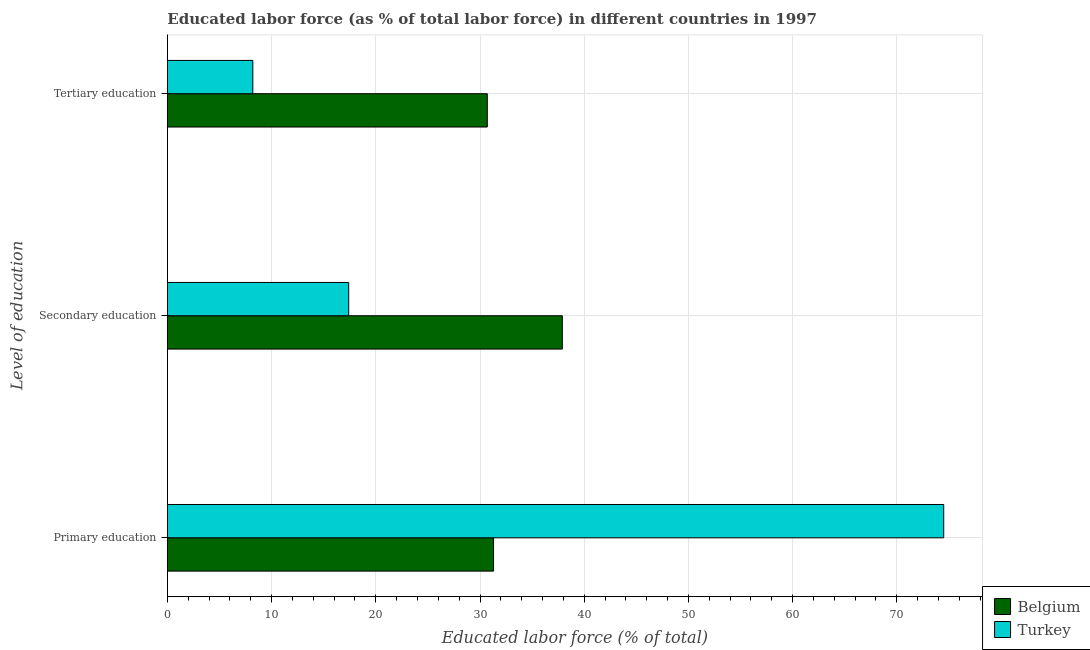How many different coloured bars are there?
Keep it short and to the point. 2. How many groups of bars are there?
Provide a succinct answer. 3. How many bars are there on the 3rd tick from the top?
Provide a succinct answer. 2. What is the label of the 1st group of bars from the top?
Ensure brevity in your answer.  Tertiary education. What is the percentage of labor force who received secondary education in Turkey?
Ensure brevity in your answer.  17.4. Across all countries, what is the maximum percentage of labor force who received primary education?
Give a very brief answer. 74.5. Across all countries, what is the minimum percentage of labor force who received secondary education?
Provide a succinct answer. 17.4. In which country was the percentage of labor force who received primary education minimum?
Ensure brevity in your answer.  Belgium. What is the total percentage of labor force who received tertiary education in the graph?
Your answer should be very brief. 38.9. What is the difference between the percentage of labor force who received primary education in Turkey and that in Belgium?
Provide a short and direct response. 43.2. What is the difference between the percentage of labor force who received primary education in Belgium and the percentage of labor force who received tertiary education in Turkey?
Keep it short and to the point. 23.1. What is the average percentage of labor force who received tertiary education per country?
Your answer should be very brief. 19.45. What is the difference between the percentage of labor force who received tertiary education and percentage of labor force who received primary education in Belgium?
Your answer should be very brief. -0.6. What is the ratio of the percentage of labor force who received secondary education in Turkey to that in Belgium?
Your answer should be compact. 0.46. What is the difference between the highest and the second highest percentage of labor force who received tertiary education?
Your answer should be very brief. 22.5. What is the difference between the highest and the lowest percentage of labor force who received primary education?
Provide a short and direct response. 43.2. What does the 1st bar from the top in Tertiary education represents?
Make the answer very short. Turkey. What does the 1st bar from the bottom in Tertiary education represents?
Give a very brief answer. Belgium. Is it the case that in every country, the sum of the percentage of labor force who received primary education and percentage of labor force who received secondary education is greater than the percentage of labor force who received tertiary education?
Give a very brief answer. Yes. How many bars are there?
Your answer should be very brief. 6. Are all the bars in the graph horizontal?
Offer a terse response. Yes. How many countries are there in the graph?
Your answer should be very brief. 2. What is the difference between two consecutive major ticks on the X-axis?
Provide a short and direct response. 10. Are the values on the major ticks of X-axis written in scientific E-notation?
Your answer should be compact. No. Does the graph contain any zero values?
Give a very brief answer. No. Does the graph contain grids?
Provide a short and direct response. Yes. Where does the legend appear in the graph?
Offer a very short reply. Bottom right. How many legend labels are there?
Your response must be concise. 2. How are the legend labels stacked?
Make the answer very short. Vertical. What is the title of the graph?
Make the answer very short. Educated labor force (as % of total labor force) in different countries in 1997. Does "Bahrain" appear as one of the legend labels in the graph?
Your answer should be very brief. No. What is the label or title of the X-axis?
Your answer should be compact. Educated labor force (% of total). What is the label or title of the Y-axis?
Give a very brief answer. Level of education. What is the Educated labor force (% of total) in Belgium in Primary education?
Provide a succinct answer. 31.3. What is the Educated labor force (% of total) in Turkey in Primary education?
Your answer should be very brief. 74.5. What is the Educated labor force (% of total) of Belgium in Secondary education?
Make the answer very short. 37.9. What is the Educated labor force (% of total) of Turkey in Secondary education?
Your response must be concise. 17.4. What is the Educated labor force (% of total) in Belgium in Tertiary education?
Make the answer very short. 30.7. What is the Educated labor force (% of total) in Turkey in Tertiary education?
Provide a succinct answer. 8.2. Across all Level of education, what is the maximum Educated labor force (% of total) of Belgium?
Give a very brief answer. 37.9. Across all Level of education, what is the maximum Educated labor force (% of total) in Turkey?
Provide a succinct answer. 74.5. Across all Level of education, what is the minimum Educated labor force (% of total) of Belgium?
Your answer should be compact. 30.7. Across all Level of education, what is the minimum Educated labor force (% of total) of Turkey?
Your answer should be very brief. 8.2. What is the total Educated labor force (% of total) of Belgium in the graph?
Your answer should be compact. 99.9. What is the total Educated labor force (% of total) in Turkey in the graph?
Provide a short and direct response. 100.1. What is the difference between the Educated labor force (% of total) in Belgium in Primary education and that in Secondary education?
Your response must be concise. -6.6. What is the difference between the Educated labor force (% of total) in Turkey in Primary education and that in Secondary education?
Offer a terse response. 57.1. What is the difference between the Educated labor force (% of total) of Turkey in Primary education and that in Tertiary education?
Offer a terse response. 66.3. What is the difference between the Educated labor force (% of total) in Turkey in Secondary education and that in Tertiary education?
Provide a succinct answer. 9.2. What is the difference between the Educated labor force (% of total) of Belgium in Primary education and the Educated labor force (% of total) of Turkey in Secondary education?
Your response must be concise. 13.9. What is the difference between the Educated labor force (% of total) in Belgium in Primary education and the Educated labor force (% of total) in Turkey in Tertiary education?
Make the answer very short. 23.1. What is the difference between the Educated labor force (% of total) in Belgium in Secondary education and the Educated labor force (% of total) in Turkey in Tertiary education?
Provide a succinct answer. 29.7. What is the average Educated labor force (% of total) in Belgium per Level of education?
Provide a short and direct response. 33.3. What is the average Educated labor force (% of total) in Turkey per Level of education?
Ensure brevity in your answer.  33.37. What is the difference between the Educated labor force (% of total) of Belgium and Educated labor force (% of total) of Turkey in Primary education?
Your answer should be compact. -43.2. What is the difference between the Educated labor force (% of total) of Belgium and Educated labor force (% of total) of Turkey in Secondary education?
Your response must be concise. 20.5. What is the ratio of the Educated labor force (% of total) in Belgium in Primary education to that in Secondary education?
Your response must be concise. 0.83. What is the ratio of the Educated labor force (% of total) in Turkey in Primary education to that in Secondary education?
Offer a very short reply. 4.28. What is the ratio of the Educated labor force (% of total) of Belgium in Primary education to that in Tertiary education?
Give a very brief answer. 1.02. What is the ratio of the Educated labor force (% of total) of Turkey in Primary education to that in Tertiary education?
Make the answer very short. 9.09. What is the ratio of the Educated labor force (% of total) of Belgium in Secondary education to that in Tertiary education?
Provide a short and direct response. 1.23. What is the ratio of the Educated labor force (% of total) of Turkey in Secondary education to that in Tertiary education?
Ensure brevity in your answer.  2.12. What is the difference between the highest and the second highest Educated labor force (% of total) in Turkey?
Keep it short and to the point. 57.1. What is the difference between the highest and the lowest Educated labor force (% of total) in Belgium?
Make the answer very short. 7.2. What is the difference between the highest and the lowest Educated labor force (% of total) of Turkey?
Make the answer very short. 66.3. 